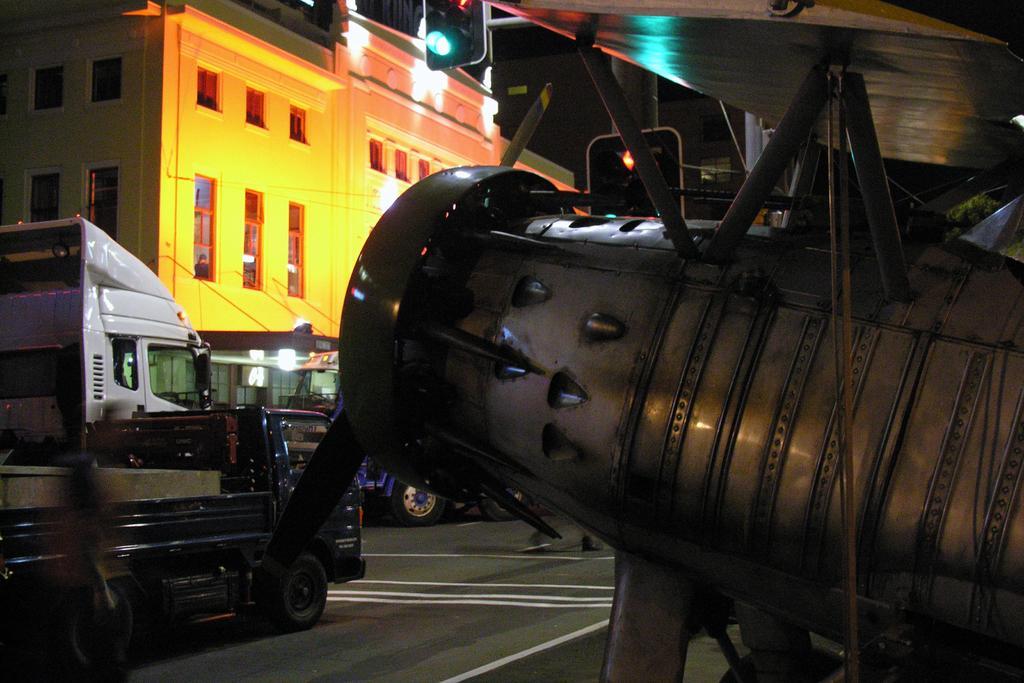Can you describe this image briefly? This image is taken during the night time. In this image we can see the buildings, lights, light pole, wires and also the vehicles passing on the road. On the right we can see the jet. 